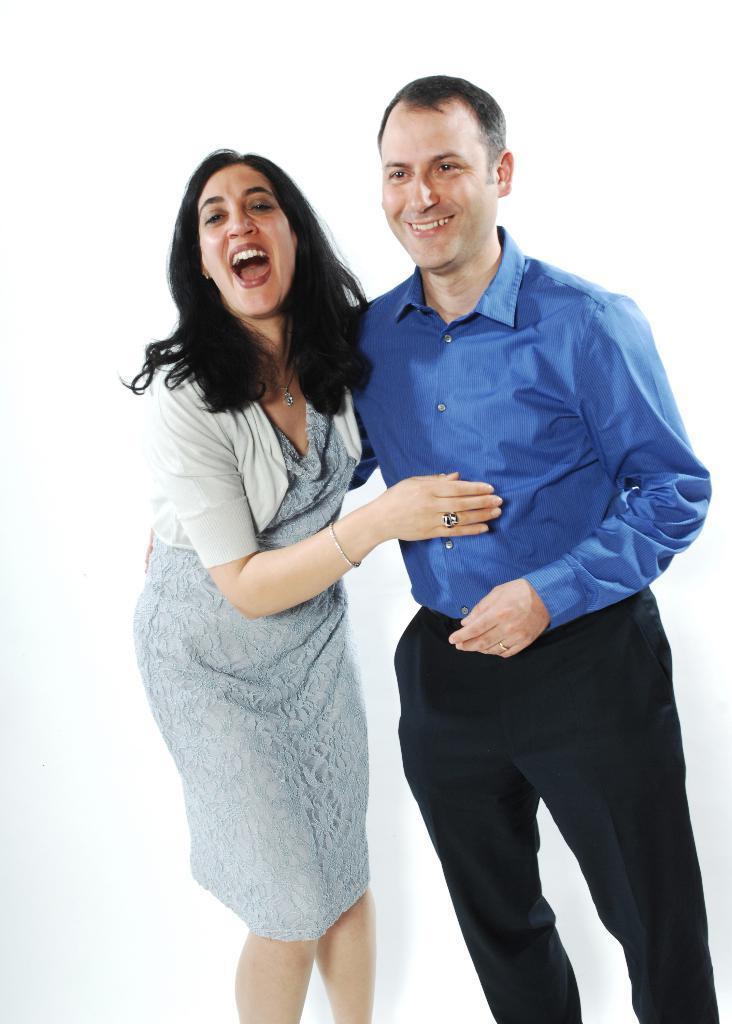Describe this image in one or two sentences. In this image we can see a man and a woman. Man is wearing blue color shirt with black pant. And the woman is wearing grey color dress and some jewelry. 